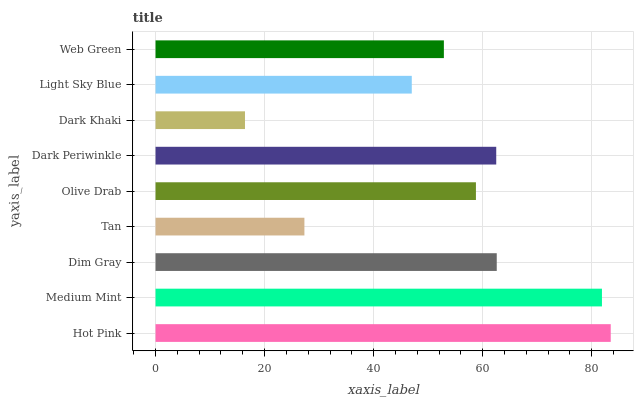Is Dark Khaki the minimum?
Answer yes or no. Yes. Is Hot Pink the maximum?
Answer yes or no. Yes. Is Medium Mint the minimum?
Answer yes or no. No. Is Medium Mint the maximum?
Answer yes or no. No. Is Hot Pink greater than Medium Mint?
Answer yes or no. Yes. Is Medium Mint less than Hot Pink?
Answer yes or no. Yes. Is Medium Mint greater than Hot Pink?
Answer yes or no. No. Is Hot Pink less than Medium Mint?
Answer yes or no. No. Is Olive Drab the high median?
Answer yes or no. Yes. Is Olive Drab the low median?
Answer yes or no. Yes. Is Dark Periwinkle the high median?
Answer yes or no. No. Is Medium Mint the low median?
Answer yes or no. No. 